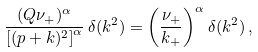<formula> <loc_0><loc_0><loc_500><loc_500>\frac { ( Q \nu _ { + } ) ^ { \alpha } } { \left [ ( p + k ) ^ { 2 } \right ] ^ { \alpha } } \, \delta ( k ^ { 2 } ) = \left ( \frac { \nu _ { + } } { k _ { + } } \right ) ^ { \alpha } \delta ( k ^ { 2 } ) \, ,</formula> 